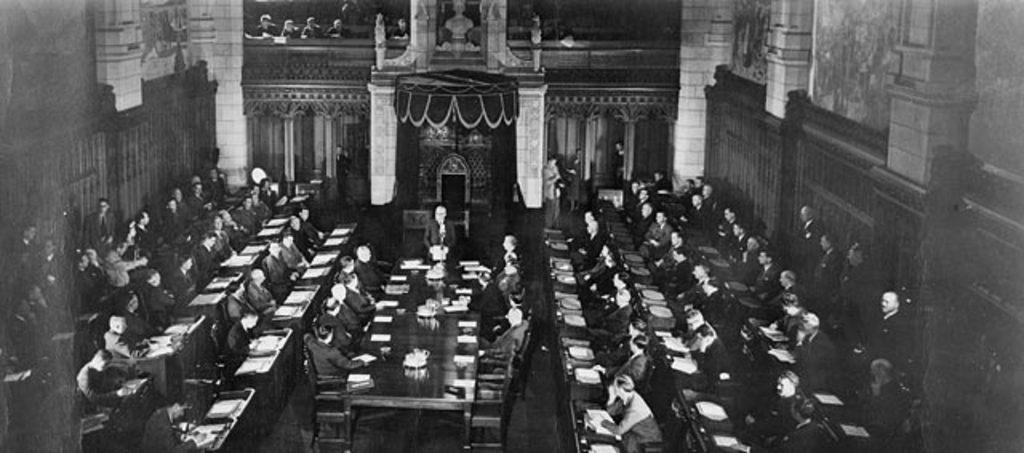What are the people in the image doing? There is a group of persons sitting on chairs in the image. What is on the floor in the image? There is a table on the floor in the image. Can you describe the position of one person in the image? One person is standing in the image. What can be seen in the background of the image? There are curtains and poles in the background of the image. Is there any rain visible in the image? There is no rain present in the image. What type of suit is the floor wearing in the image? The floor is not a person and therefore cannot wear a suit. 